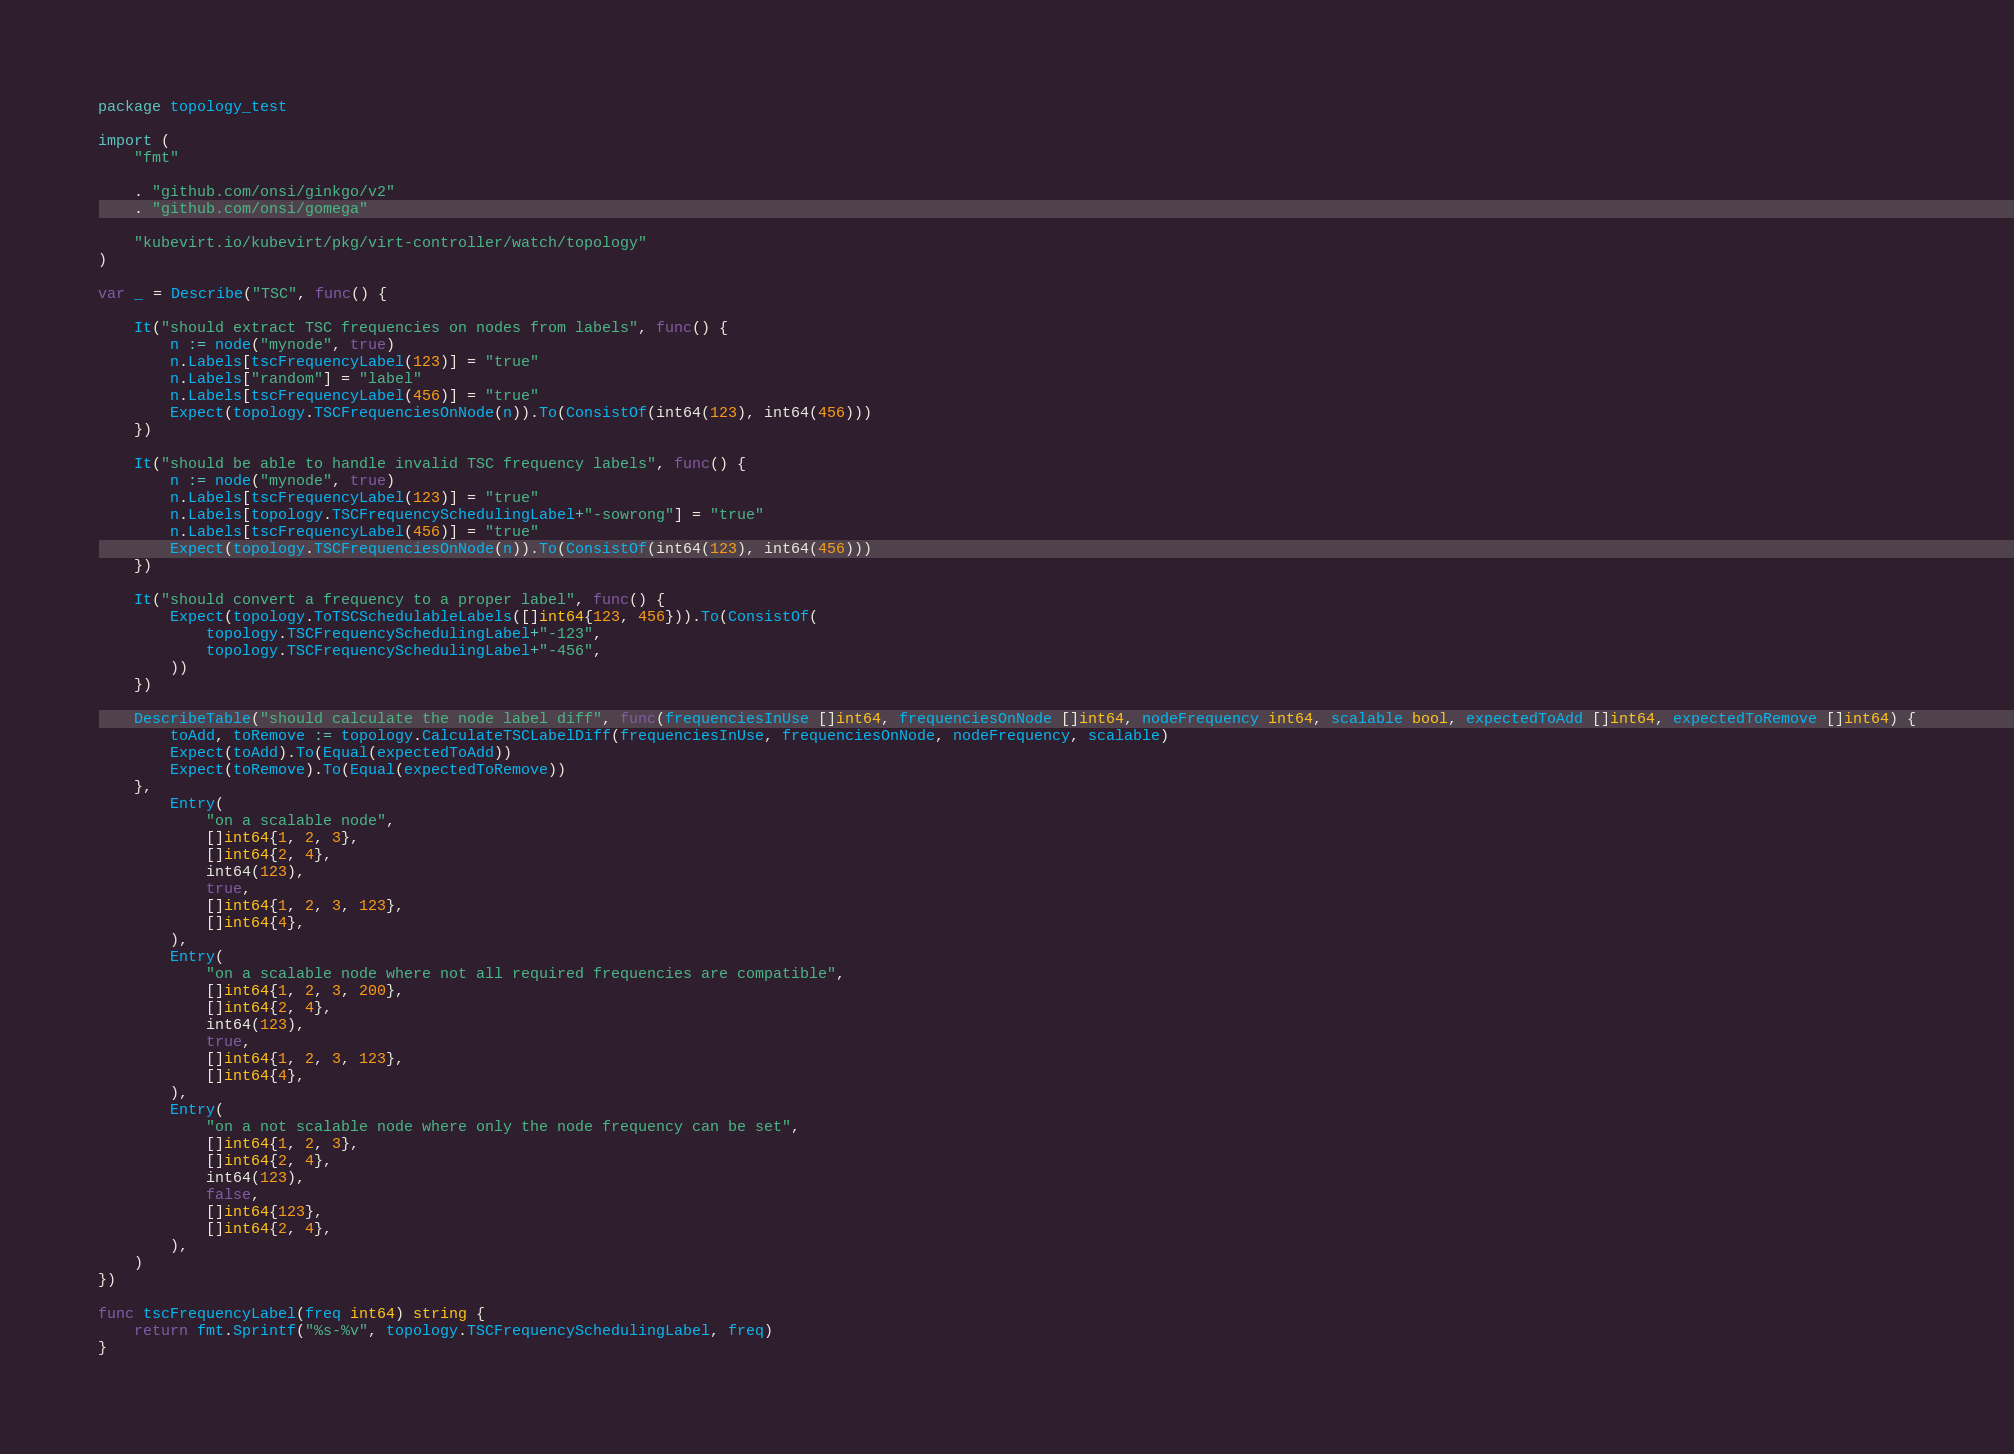Convert code to text. <code><loc_0><loc_0><loc_500><loc_500><_Go_>package topology_test

import (
	"fmt"

	. "github.com/onsi/ginkgo/v2"
	. "github.com/onsi/gomega"

	"kubevirt.io/kubevirt/pkg/virt-controller/watch/topology"
)

var _ = Describe("TSC", func() {

	It("should extract TSC frequencies on nodes from labels", func() {
		n := node("mynode", true)
		n.Labels[tscFrequencyLabel(123)] = "true"
		n.Labels["random"] = "label"
		n.Labels[tscFrequencyLabel(456)] = "true"
		Expect(topology.TSCFrequenciesOnNode(n)).To(ConsistOf(int64(123), int64(456)))
	})

	It("should be able to handle invalid TSC frequency labels", func() {
		n := node("mynode", true)
		n.Labels[tscFrequencyLabel(123)] = "true"
		n.Labels[topology.TSCFrequencySchedulingLabel+"-sowrong"] = "true"
		n.Labels[tscFrequencyLabel(456)] = "true"
		Expect(topology.TSCFrequenciesOnNode(n)).To(ConsistOf(int64(123), int64(456)))
	})

	It("should convert a frequency to a proper label", func() {
		Expect(topology.ToTSCSchedulableLabels([]int64{123, 456})).To(ConsistOf(
			topology.TSCFrequencySchedulingLabel+"-123",
			topology.TSCFrequencySchedulingLabel+"-456",
		))
	})

	DescribeTable("should calculate the node label diff", func(frequenciesInUse []int64, frequenciesOnNode []int64, nodeFrequency int64, scalable bool, expectedToAdd []int64, expectedToRemove []int64) {
		toAdd, toRemove := topology.CalculateTSCLabelDiff(frequenciesInUse, frequenciesOnNode, nodeFrequency, scalable)
		Expect(toAdd).To(Equal(expectedToAdd))
		Expect(toRemove).To(Equal(expectedToRemove))
	},
		Entry(
			"on a scalable node",
			[]int64{1, 2, 3},
			[]int64{2, 4},
			int64(123),
			true,
			[]int64{1, 2, 3, 123},
			[]int64{4},
		),
		Entry(
			"on a scalable node where not all required frequencies are compatible",
			[]int64{1, 2, 3, 200},
			[]int64{2, 4},
			int64(123),
			true,
			[]int64{1, 2, 3, 123},
			[]int64{4},
		),
		Entry(
			"on a not scalable node where only the node frequency can be set",
			[]int64{1, 2, 3},
			[]int64{2, 4},
			int64(123),
			false,
			[]int64{123},
			[]int64{2, 4},
		),
	)
})

func tscFrequencyLabel(freq int64) string {
	return fmt.Sprintf("%s-%v", topology.TSCFrequencySchedulingLabel, freq)
}
</code> 